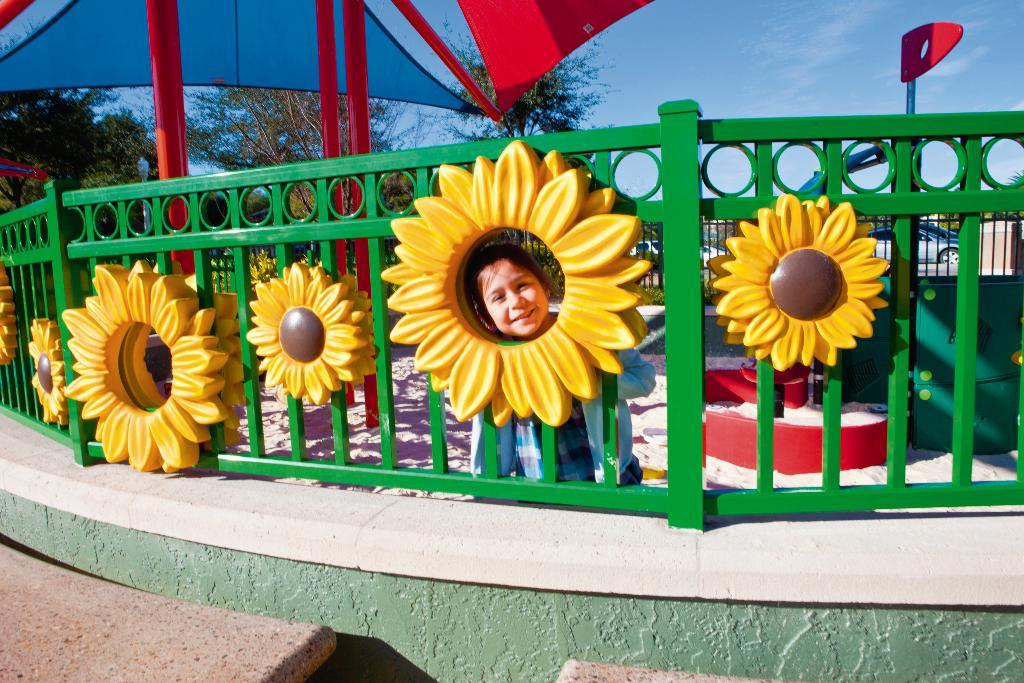Who is present in the image? There is a child in the image. What is the child's expression? The child is smiling. What can be seen in the background of the image? The sky is visible in the background of the image. What is the child standing near? There is a fence in the image. What is the child holding? There is an umbrella in the image. What type of vegetation is visible in the image? There are trees in the image. What else can be seen in the image? There are vehicles and some objects in the image. What type of glue is being used to hold the corn in the image? There is no glue or corn present in the image. What type of oatmeal is being served in the image? There is no oatmeal present in the image. 